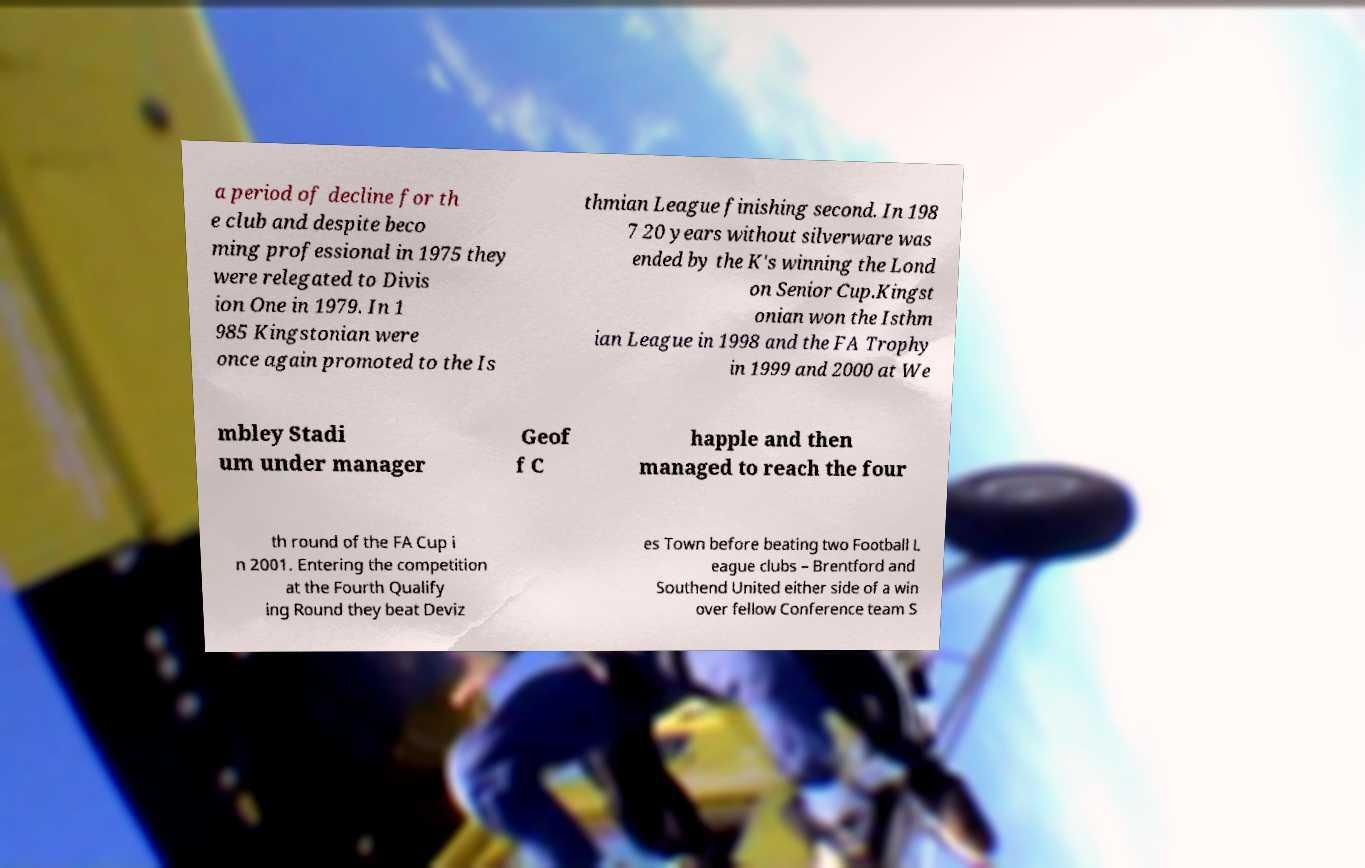Can you read and provide the text displayed in the image?This photo seems to have some interesting text. Can you extract and type it out for me? a period of decline for th e club and despite beco ming professional in 1975 they were relegated to Divis ion One in 1979. In 1 985 Kingstonian were once again promoted to the Is thmian League finishing second. In 198 7 20 years without silverware was ended by the K's winning the Lond on Senior Cup.Kingst onian won the Isthm ian League in 1998 and the FA Trophy in 1999 and 2000 at We mbley Stadi um under manager Geof f C happle and then managed to reach the four th round of the FA Cup i n 2001. Entering the competition at the Fourth Qualify ing Round they beat Deviz es Town before beating two Football L eague clubs – Brentford and Southend United either side of a win over fellow Conference team S 